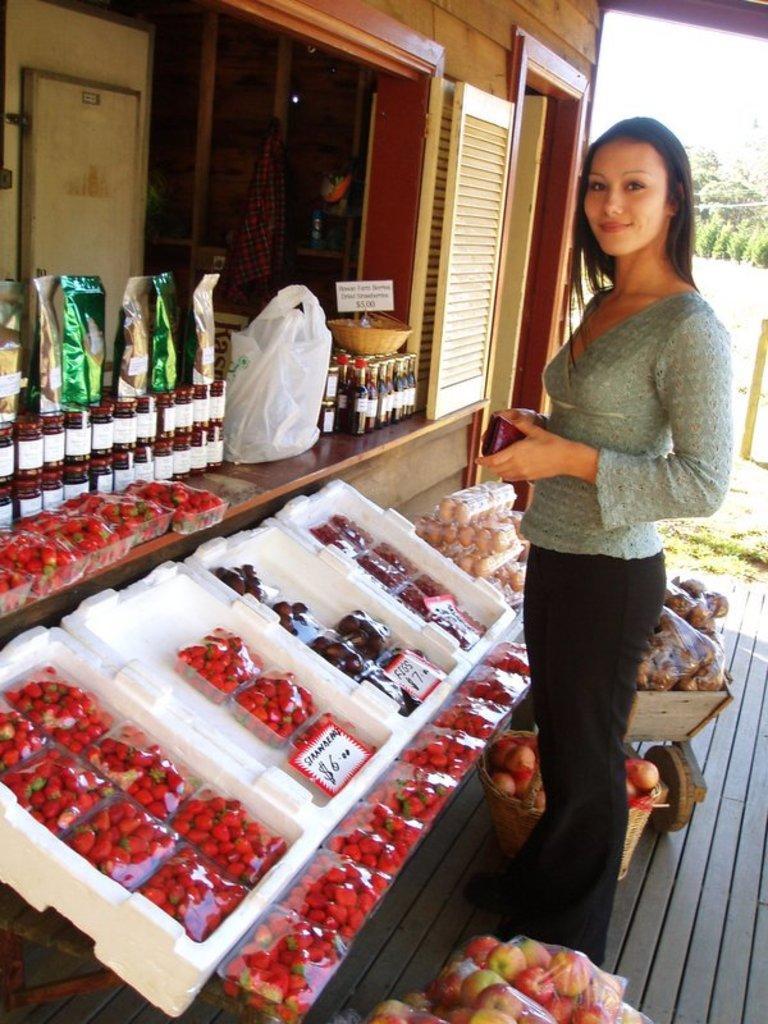Can you describe this image briefly? In this image we can see a woman is standing, in front there are many fruits, there are strawberries in a box, there is a price tag, in front there are bottles, and food packets on a table, beside there is a polythene cover, there is a basket, there is a door, there are trees. 